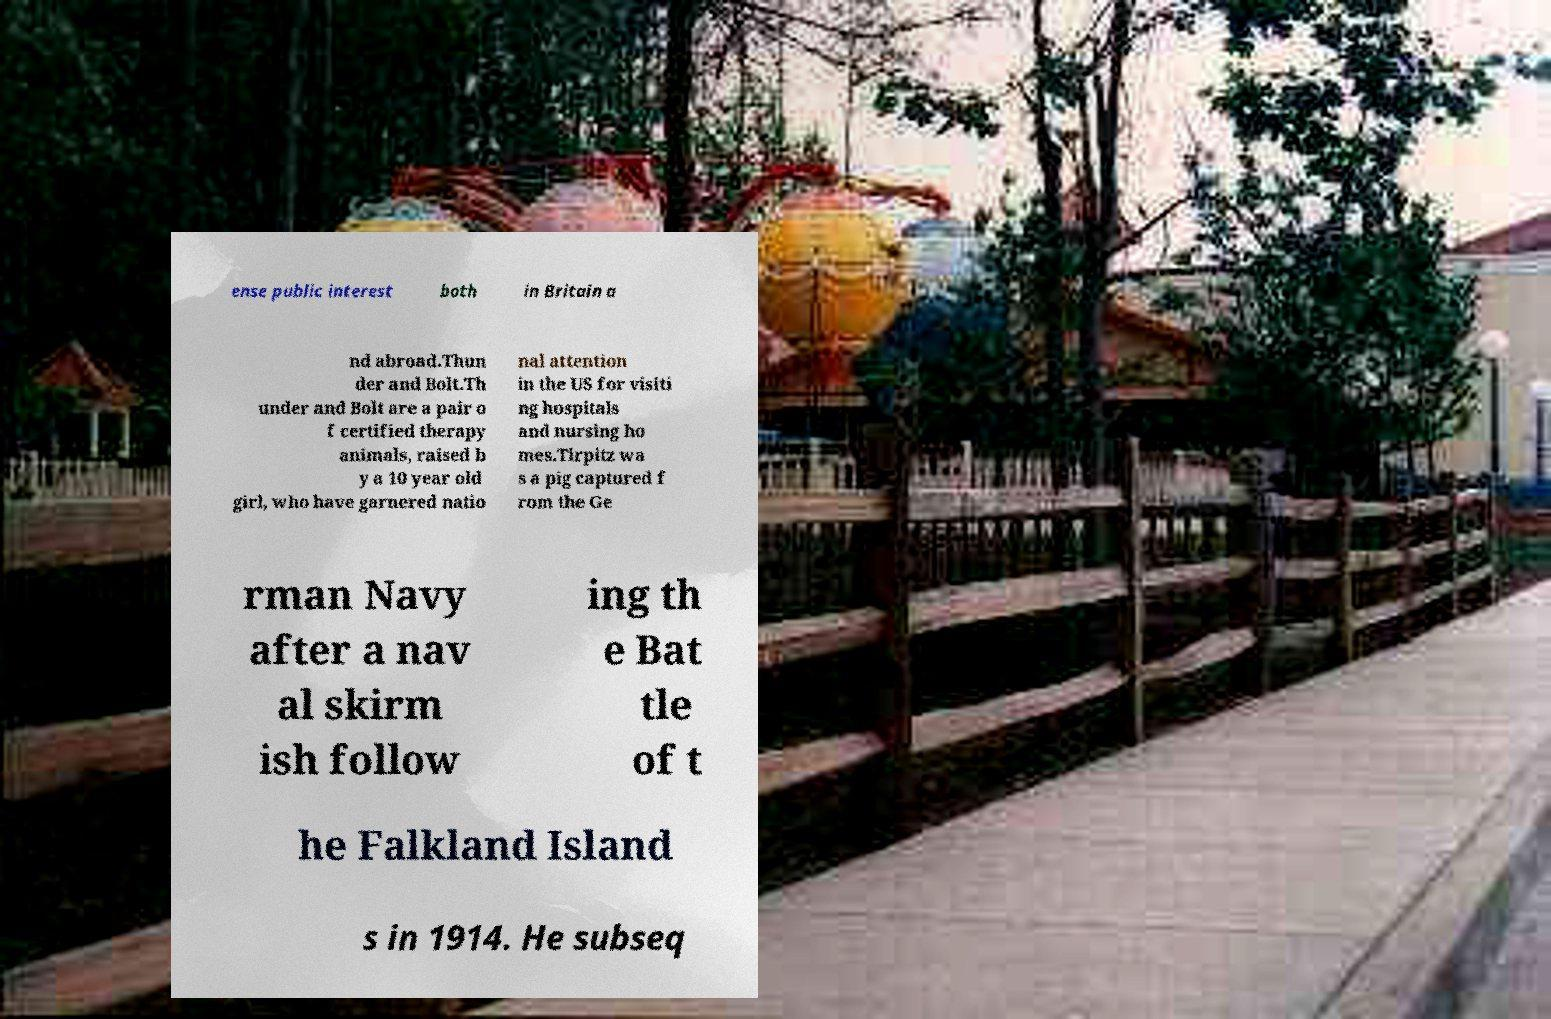Can you accurately transcribe the text from the provided image for me? ense public interest both in Britain a nd abroad.Thun der and Bolt.Th under and Bolt are a pair o f certified therapy animals, raised b y a 10 year old girl, who have garnered natio nal attention in the US for visiti ng hospitals and nursing ho mes.Tirpitz wa s a pig captured f rom the Ge rman Navy after a nav al skirm ish follow ing th e Bat tle of t he Falkland Island s in 1914. He subseq 